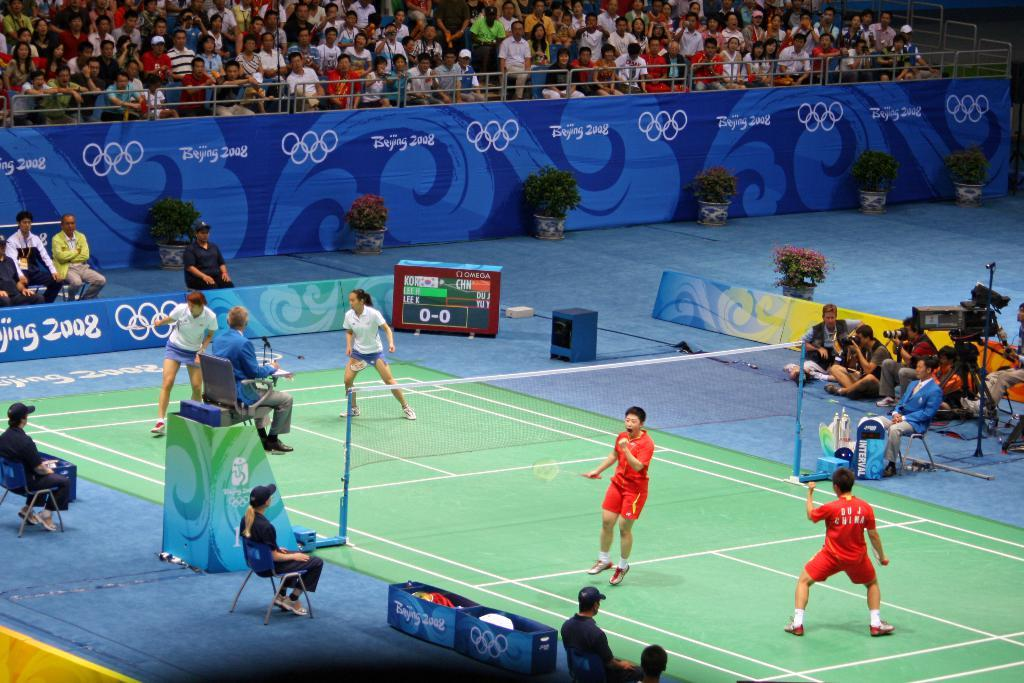<image>
Offer a succinct explanation of the picture presented. a man playing tennis with Du J China wrote on his shirt 